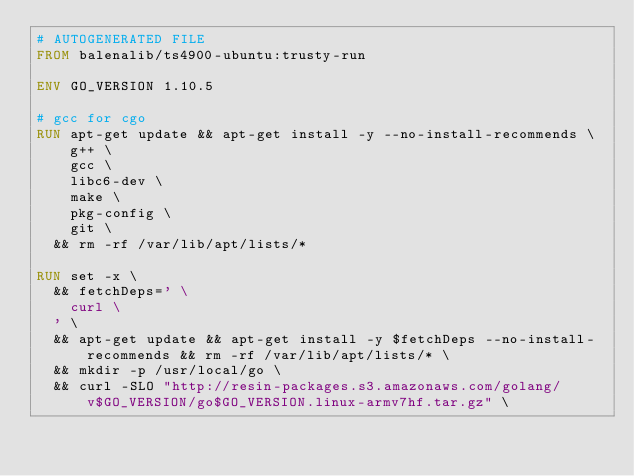Convert code to text. <code><loc_0><loc_0><loc_500><loc_500><_Dockerfile_># AUTOGENERATED FILE
FROM balenalib/ts4900-ubuntu:trusty-run

ENV GO_VERSION 1.10.5

# gcc for cgo
RUN apt-get update && apt-get install -y --no-install-recommends \
		g++ \
		gcc \
		libc6-dev \
		make \
		pkg-config \
		git \
	&& rm -rf /var/lib/apt/lists/*

RUN set -x \
	&& fetchDeps=' \
		curl \
	' \
	&& apt-get update && apt-get install -y $fetchDeps --no-install-recommends && rm -rf /var/lib/apt/lists/* \
	&& mkdir -p /usr/local/go \
	&& curl -SLO "http://resin-packages.s3.amazonaws.com/golang/v$GO_VERSION/go$GO_VERSION.linux-armv7hf.tar.gz" \</code> 